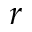<formula> <loc_0><loc_0><loc_500><loc_500>r</formula> 